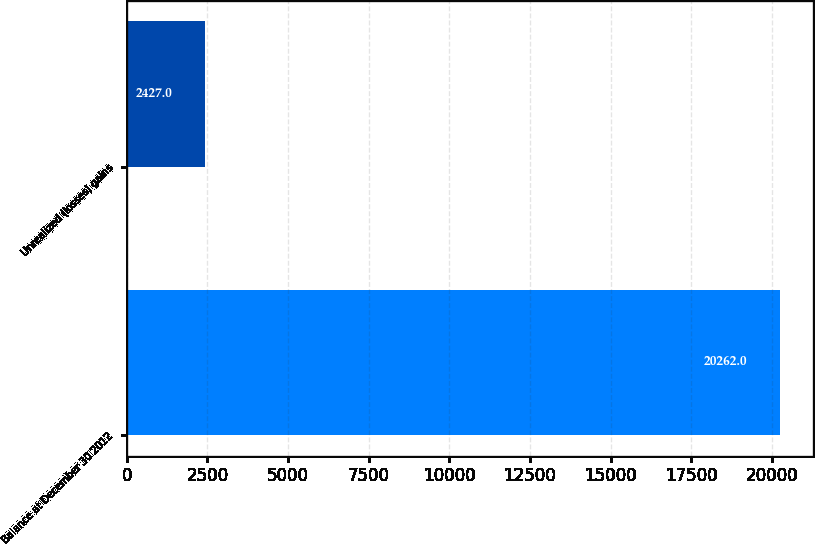Convert chart. <chart><loc_0><loc_0><loc_500><loc_500><bar_chart><fcel>Balance at December 30 2012<fcel>Unrealized (losses) gains<nl><fcel>20262<fcel>2427<nl></chart> 